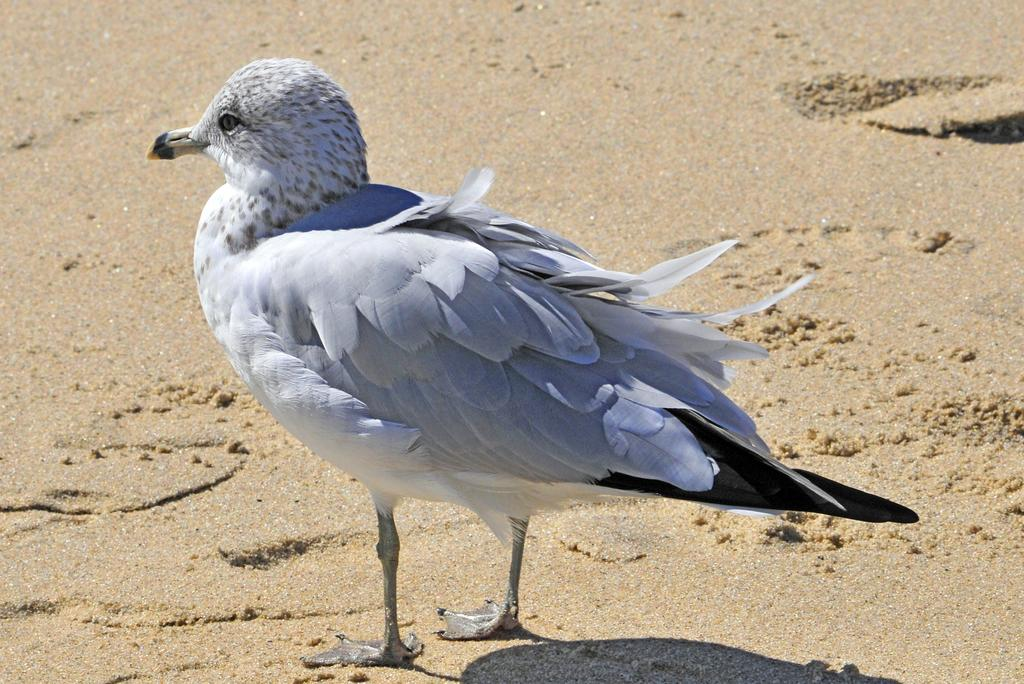What type of animal can be seen in the image? There is a bird in the image. Where is the bird located? The bird is standing on the beach. What song is the bird singing in the image? The image does not provide any information about the bird singing a song, so we cannot answer that question. 